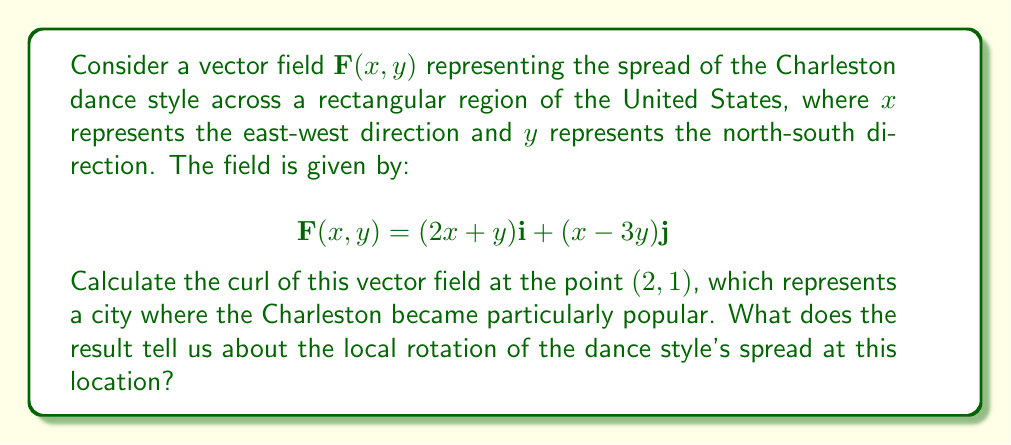Could you help me with this problem? To solve this problem, we'll follow these steps:

1) The curl of a vector field $\mathbf{F}(x,y) = P(x,y)\mathbf{i} + Q(x,y)\mathbf{j}$ in two dimensions is given by:

   $$\text{curl }\mathbf{F} = \nabla \times \mathbf{F} = \left(\frac{\partial Q}{\partial x} - \frac{\partial P}{\partial y}\right)\mathbf{k}$$

2) In our case, $P(x,y) = 2x+y$ and $Q(x,y) = x-3y$

3) Let's calculate the partial derivatives:
   
   $\frac{\partial Q}{\partial x} = \frac{\partial}{\partial x}(x-3y) = 1$
   
   $\frac{\partial P}{\partial y} = \frac{\partial}{\partial y}(2x+y) = 1$

4) Now, we can calculate the curl:

   $$\text{curl }\mathbf{F} = \left(\frac{\partial Q}{\partial x} - \frac{\partial P}{\partial y}\right)\mathbf{k} = (1 - 1)\mathbf{k} = 0\mathbf{k}$$

5) The curl is zero everywhere, including at the point $(2,1)$.

This result indicates that there is no local rotation in the spread of the Charleston dance style at the point $(2,1)$ or anywhere else in the region. The dance style is spreading without any rotational component, suggesting a uniform diffusion rather than a swirling pattern.
Answer: $0\mathbf{k}$ 